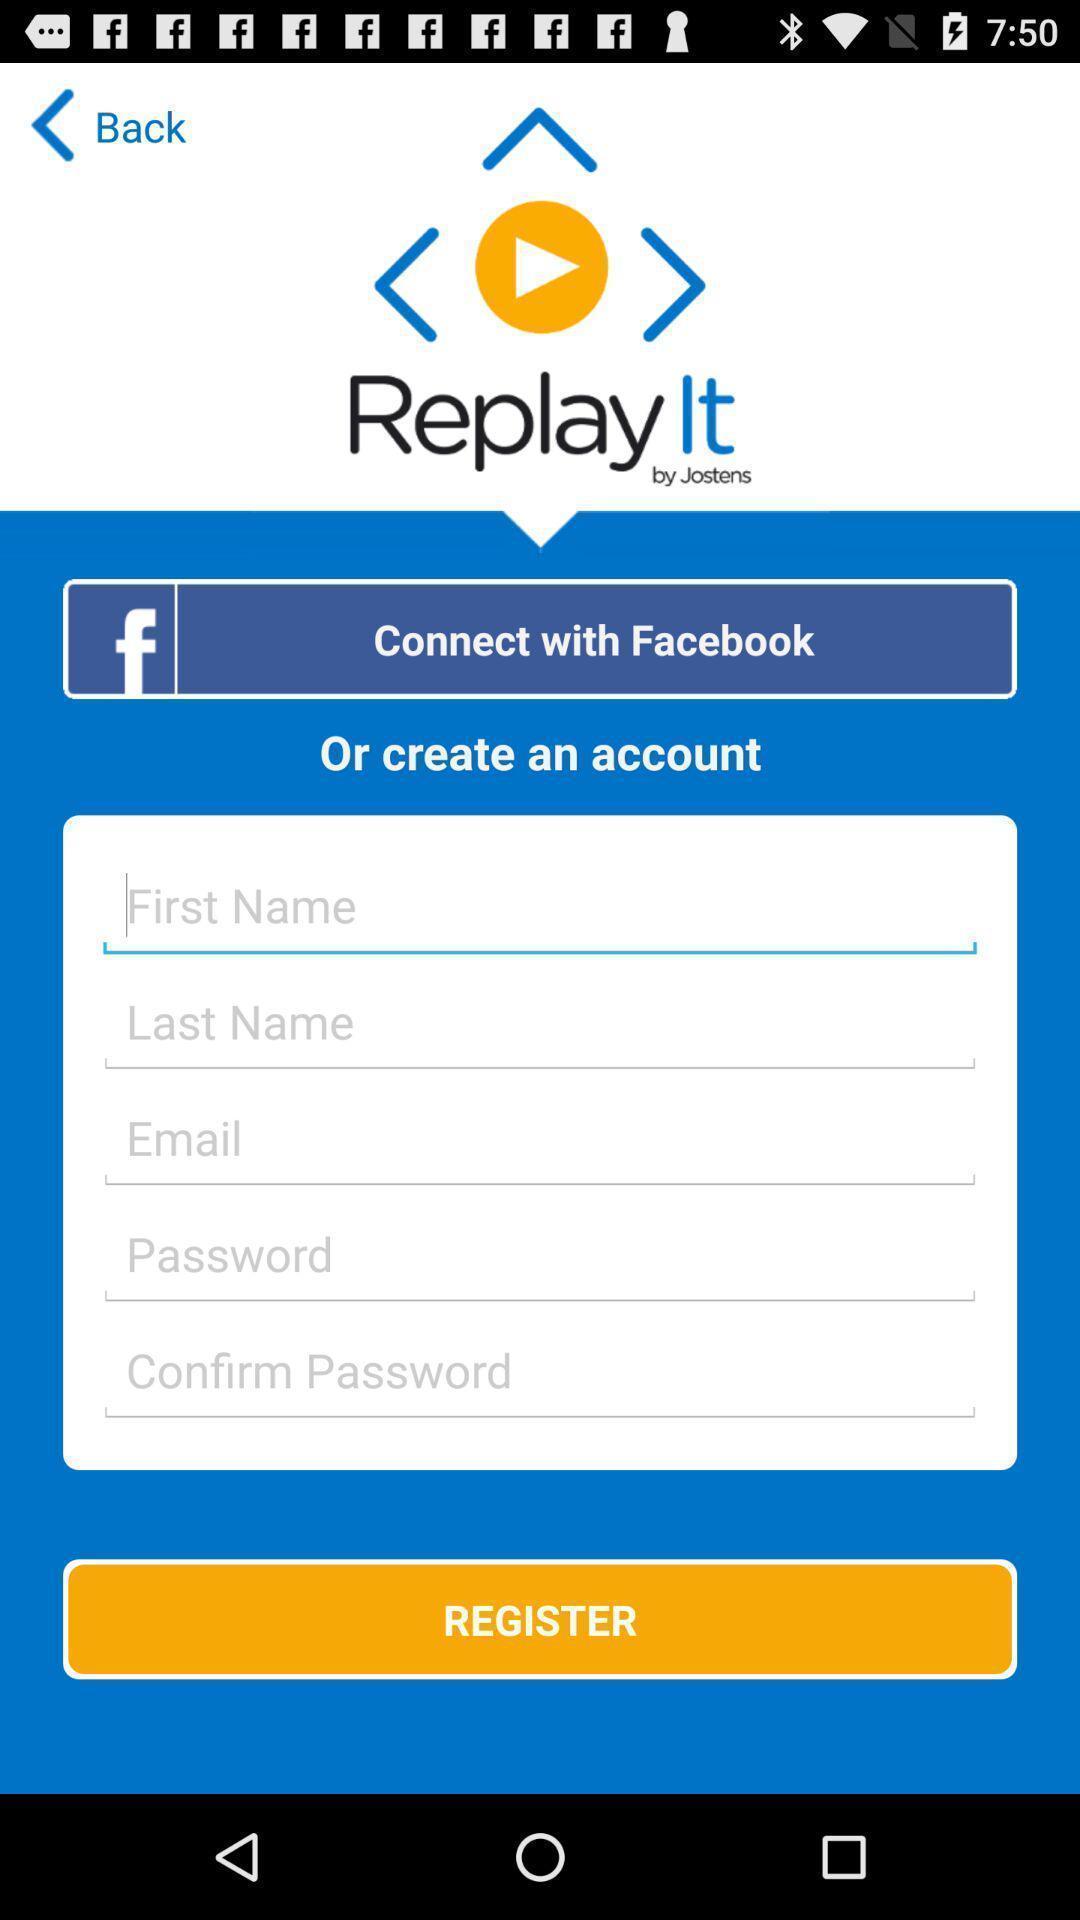Give me a summary of this screen capture. Welcome to the sign up page. 